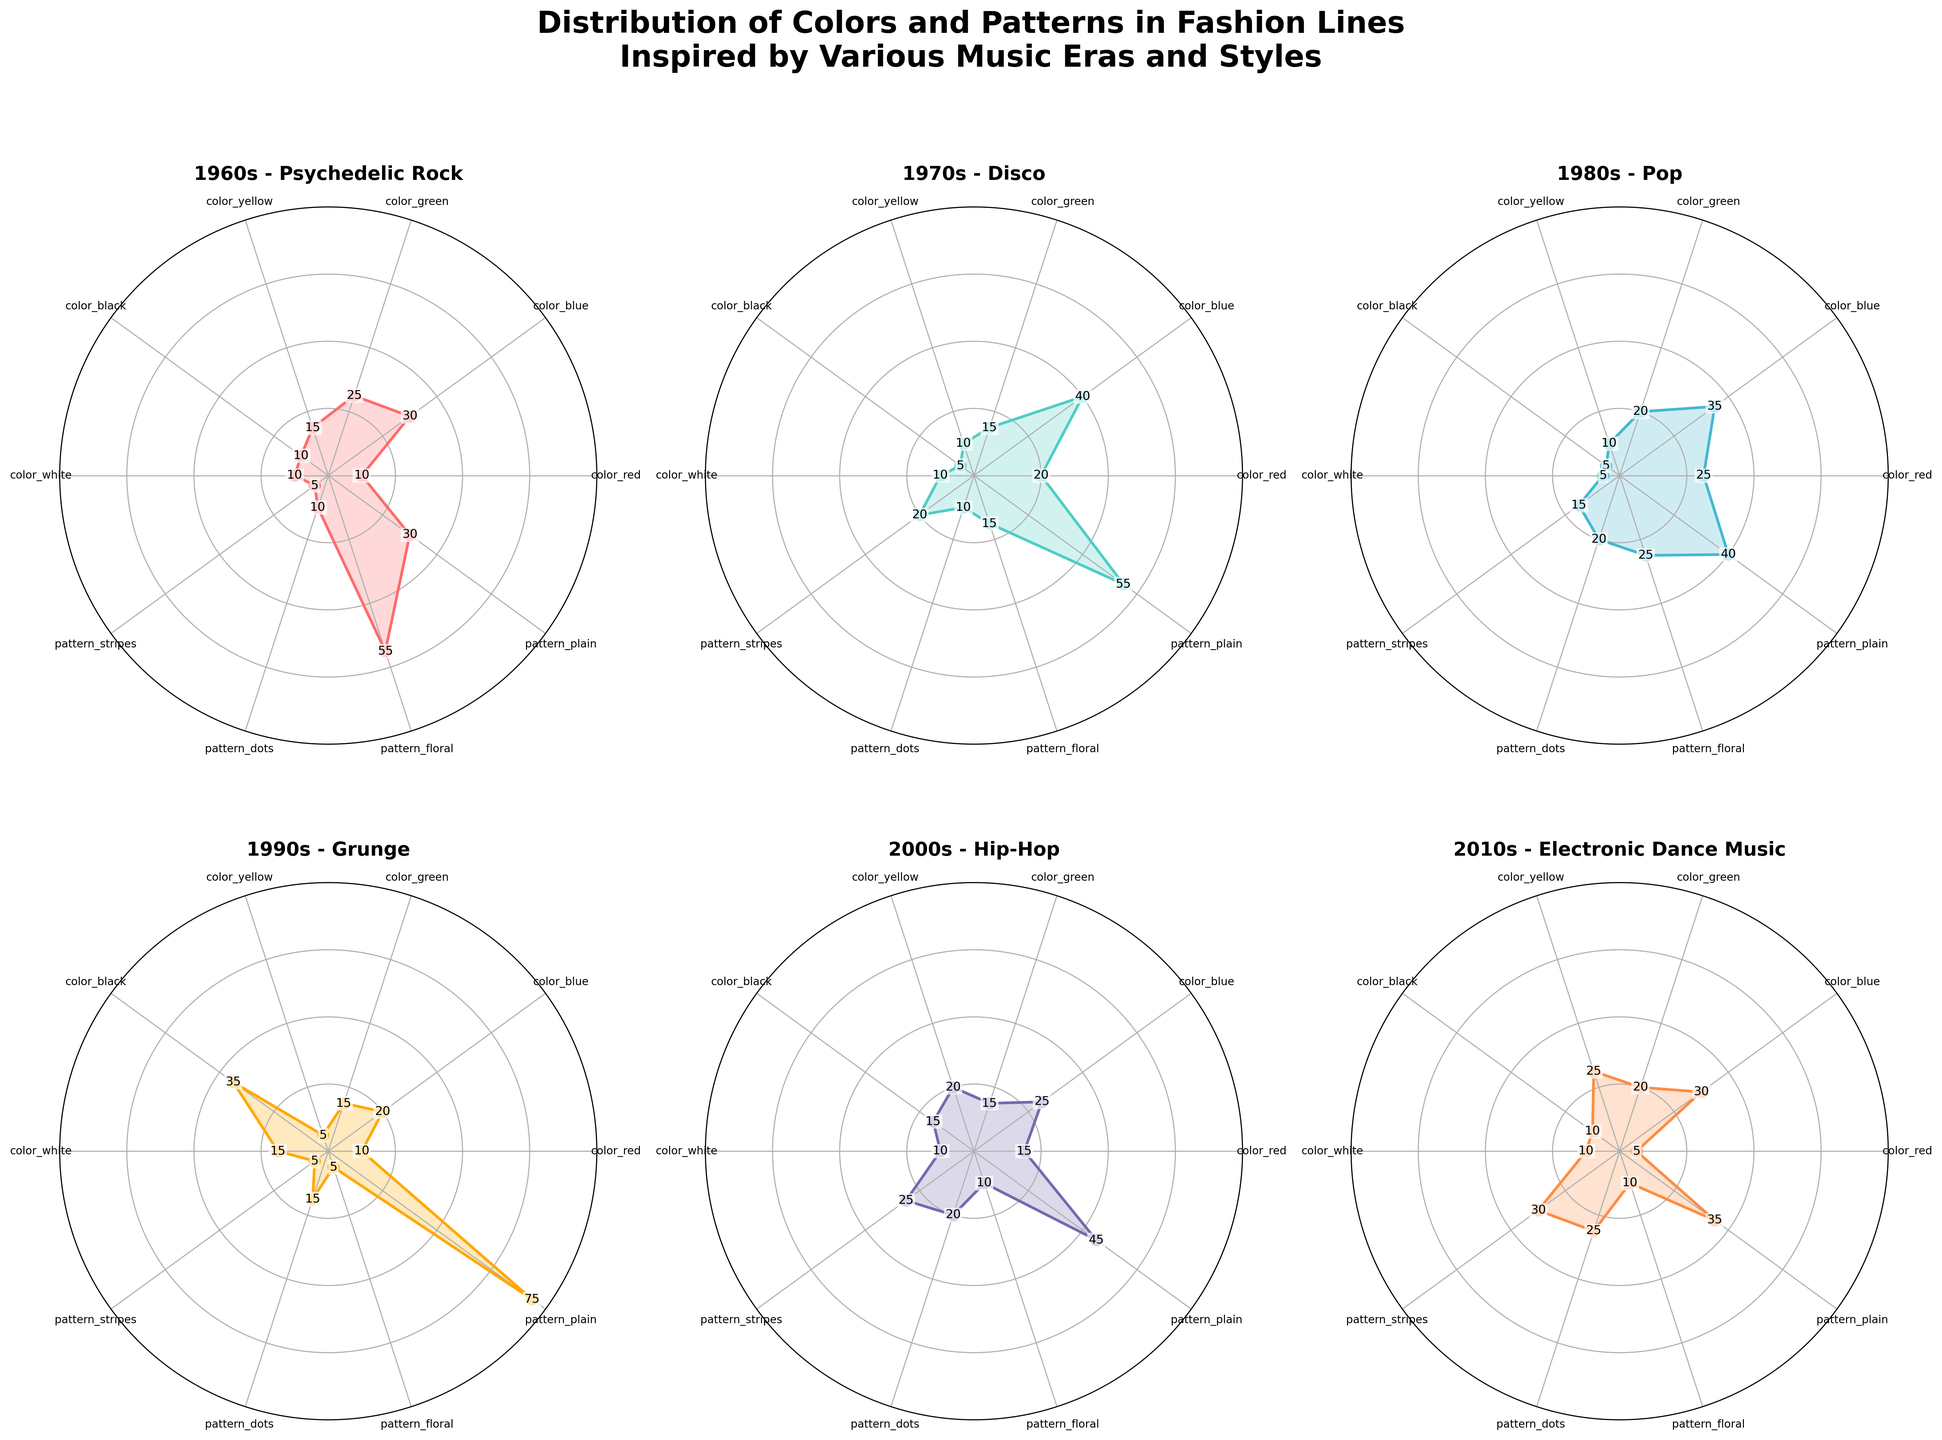How many different music eras are represented in the figure? The figure includes a subplot for each music era. By counting the number of subplots, we can determine the number of music eras. There are 6 subplots corresponding to 6 music eras: 1960s, 1970s, 1980s, 1990s, 2000s, and 2010s.
Answer: 6 Which music era has the highest value for the 'pattern_plain' category? To determine which music era has the highest value for 'pattern_plain', we can compare the values for this category across all subplots. The 1990s era shows the highest value of 75 for 'pattern_plain'.
Answer: 1990s What is the total percentage of 'color_red' across all music eras? We can sum the 'color_red' values from each era to get the total: 1960s (10) + 1970s (20) + 1980s (25) + 1990s (10) + 2000s (15) + 2010s (5) = 85. Therefore, the total percentage for 'color_red' is 85.
Answer: 85 Does any music era have equal distributions for any two categories? We need to check if any subplot has identical values for any two categories. The answer is no; no music era shows equal percentages for any two categories on the radar charts.
Answer: No Compare the distribution of 'color_blue' between the 1970s and 2000s. Which era has a higher value and by how much? The radar chart shows 'color_blue' values as 40 for the 1970s and 25 for the 2000s. The 1970s have a higher value by 15.
Answer: 1970s by 15 Which two music eras have the closest distribution values for 'pattern_stripes'? By examining the radar charts, we see that both the 1970s and 1980s have close values for 'pattern_stripes', with values of 20 and 15 respectively; the difference is 5.
Answer: 1970s and 1980s Calculate the average value for 'color_black' across all music eras. Sum the 'color_black' values for each era (10 + 5 + 5 + 35 + 15 + 10) = 80. Then, divide by the number of eras, which is 6: 80 / 6 ≈ 13.33. The average value for 'color_black' is approximately 13.33.
Answer: 13.33 Which music era has the most balanced distribution across all categories? By interpreting the radar charts, the 1970s era appears to have a fairly balanced distribution with relatively even values across different categories compared to other eras.
Answer: 1970s Among all music eras, which has the highest value for 'pattern_floral'? By observing the radar charts, the 1960s have the highest value for 'pattern_floral' at 55.
Answer: 1960s Compare the usage of 'color_yellow' in the 2010s with 'pattern_dots' in the 1980s. Which one is more prevalent and by how much? 'Color_yellow' in the 2010s has a value of 25. 'Pattern_dots' in the 1980s has a value of 20. 'Color_yellow' in the 2010s is more prevalent by 5 units.
Answer: 'color_yellow' in the 2010s by 5 